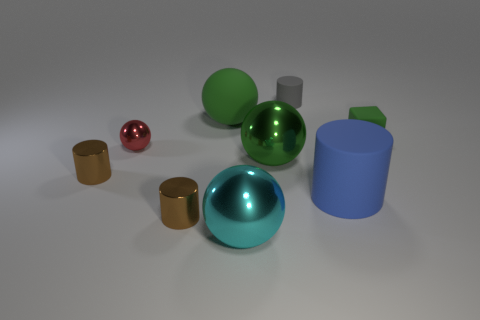What size is the shiny cylinder that is to the left of the red metallic object?
Your answer should be compact. Small. There is a cylinder that is the same size as the matte ball; what is it made of?
Your answer should be compact. Rubber. Does the large blue thing have the same shape as the tiny green matte thing?
Ensure brevity in your answer.  No. What number of objects are either large cyan spheres or large cyan metallic spheres that are to the left of the green metallic sphere?
Provide a short and direct response. 1. There is another big ball that is the same color as the large matte ball; what is it made of?
Your response must be concise. Metal. Does the green matte thing on the right side of the rubber sphere have the same size as the gray matte thing?
Provide a succinct answer. Yes. There is a matte object behind the matte object that is left of the gray cylinder; how many big blue rubber objects are behind it?
Provide a succinct answer. 0. What number of red things are blocks or big rubber balls?
Offer a terse response. 0. What is the color of the sphere that is the same material as the small gray cylinder?
Make the answer very short. Green. Is there any other thing that has the same size as the green shiny object?
Offer a terse response. Yes. 